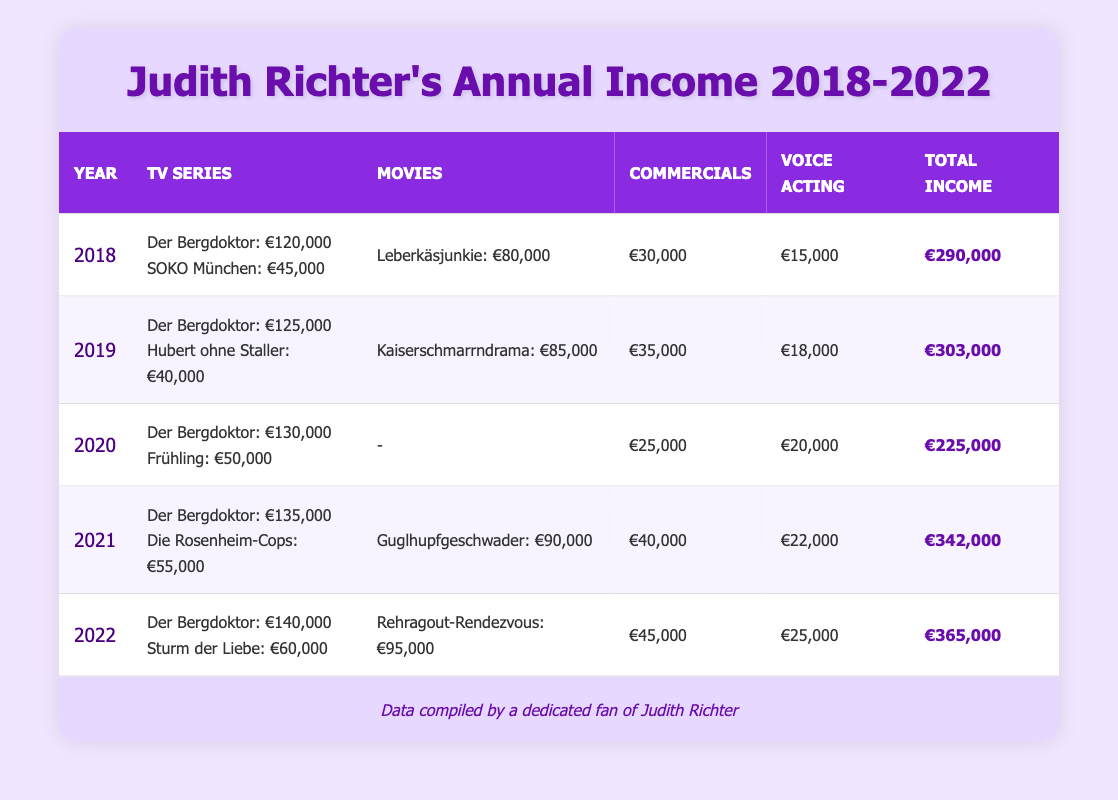What was Judith Richter's total income in 2019? In the table, under the year 2019, the total income is clearly stated as €303,000.
Answer: €303,000 Which year had the highest income from voice acting? Looking at the voice acting column across all years, the highest amount is €25,000 in 2022.
Answer: 2022 How much did Judith earn from commercials in 2021? The table shows that in 2021, the income from commercials is listed as €40,000.
Answer: €40,000 What is the average total income from 2018 to 2022? To find the average, we sum up the total incomes from each year: (€290,000 + €303,000 + €225,000 + €342,000 + €365,000) = €1,525,000. Then, divide by the number of years (5), giving us €1,525,000 / 5 = €305,000.
Answer: €305,000 Did Judith Richter earn more from movies in 2021 than in 2020? In 2021, Judith earned €90,000 from movies, while in 2020 she earned €0. Therefore, she did earn more in 2021.
Answer: Yes What was the increase in Judith's total income from 2018 to 2022? Judith's total income in 2018 was €290,000 and in 2022 it was €365,000. The increase is calculated as €365,000 - €290,000 = €75,000.
Answer: €75,000 Which TV series contributed more to Judith's income, Der Bergdoktor or the other series combined in 2020? In 2020, Judith earned €130,000 from Der Bergdoktor and €50,000 from Frühling, totaling €180,000 for other series. Since €130,000 < €180,000, Der Bergdoktor contributed less.
Answer: No In which year did Judith earn the least from commercials? By comparing the figures in the commercials column, the lowest amount is €25,000 in 2020.
Answer: 2020 What was the total income from movies in 2021 compared to 2019? In 2021, Judith earned €90,000 from movies, while in 2019 she earned €85,000. Since €90,000 > €85,000, her income from movies was higher in 2021.
Answer: Yes 